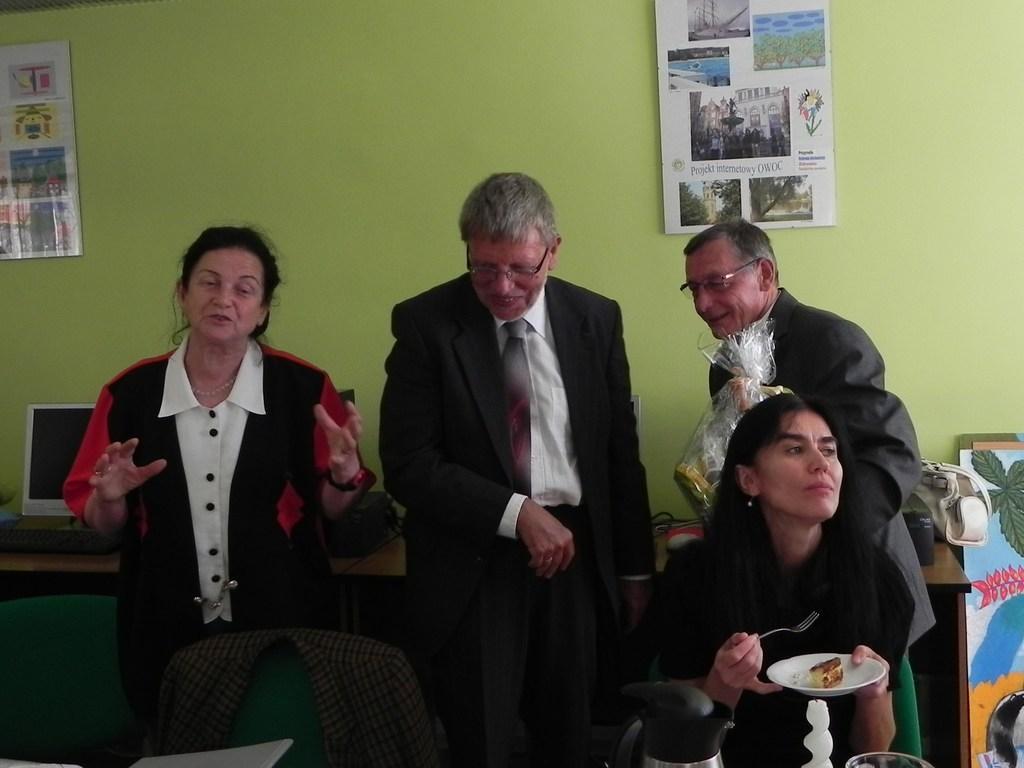In one or two sentences, can you explain what this image depicts? In this picture, we see a woman and three men are standing. The woman is trying to talk something. Three of them are smiling. In front of the picture, we see a woman is sitting on the chair and she is holding a fork and a plate containing the cake. In front of her, we see a glass jar and a glass. Beside her, we see the empty chairs. Behind them, we see a table on which computer, keyboard and other electrical goods are placed. On the right side, we see a board and a white bag. In the background, we see a green wall on which the posters are pasted. 